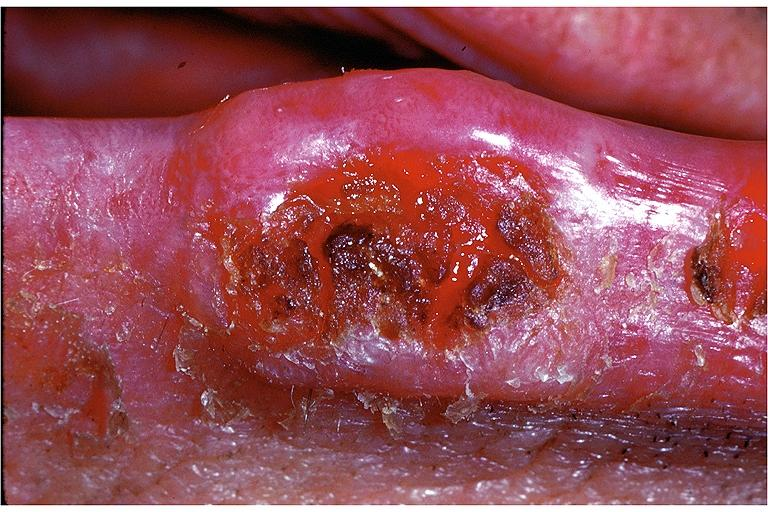does this image show squamous cell carcinoma?
Answer the question using a single word or phrase. Yes 